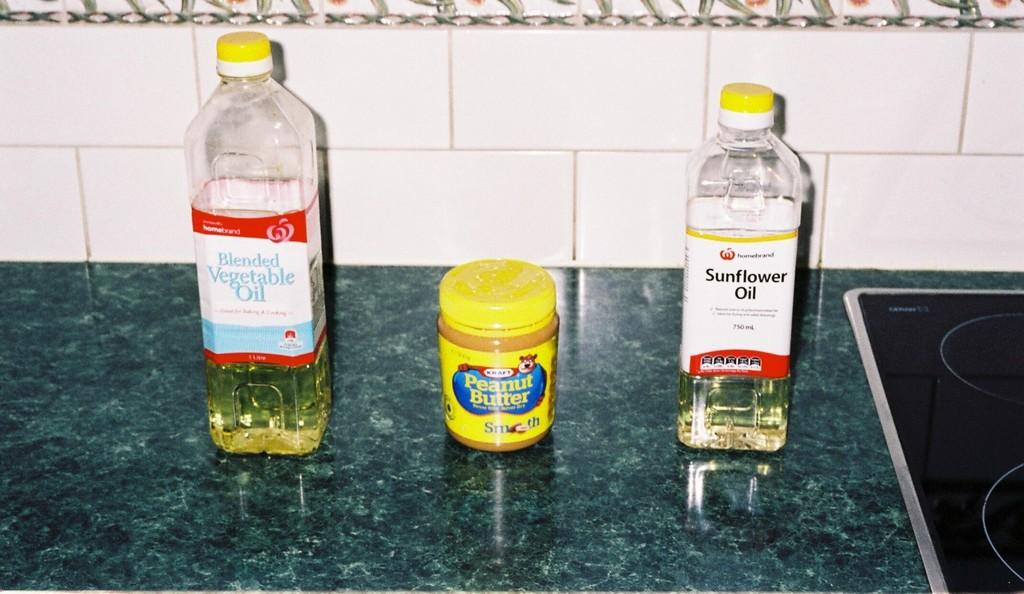<image>
Write a terse but informative summary of the picture. A peanut butter jar stands between two bottles of oil. 